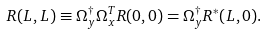<formula> <loc_0><loc_0><loc_500><loc_500>R ( L , L ) \equiv \Omega _ { y } ^ { \dagger } \Omega _ { x } ^ { T } R ( 0 , 0 ) = \Omega _ { y } ^ { \dagger } R ^ { * } ( L , 0 ) .</formula> 